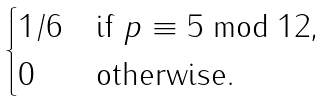<formula> <loc_0><loc_0><loc_500><loc_500>\begin{cases} 1 / 6 & \text {if $p\equiv 5\bmod 12$,} \\ 0 & \text {otherwise} . \end{cases}</formula> 